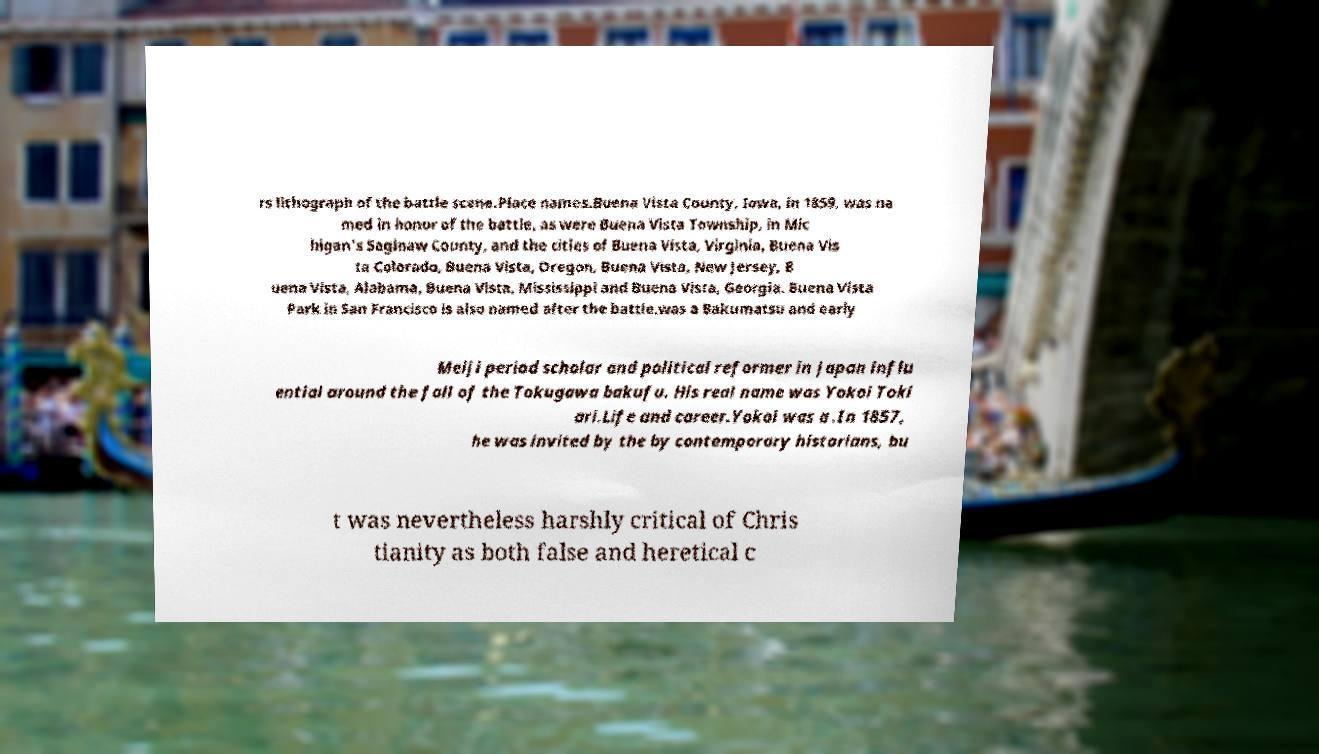For documentation purposes, I need the text within this image transcribed. Could you provide that? rs lithograph of the battle scene.Place names.Buena Vista County, Iowa, in 1859, was na med in honor of the battle, as were Buena Vista Township, in Mic higan's Saginaw County, and the cities of Buena Vista, Virginia, Buena Vis ta Colorado, Buena Vista, Oregon, Buena Vista, New Jersey, B uena Vista, Alabama, Buena Vista, Mississippi and Buena Vista, Georgia. Buena Vista Park in San Francisco is also named after the battle.was a Bakumatsu and early Meiji period scholar and political reformer in Japan influ ential around the fall of the Tokugawa bakufu. His real name was Yokoi Toki ari.Life and career.Yokoi was a .In 1857, he was invited by the by contemporary historians, bu t was nevertheless harshly critical of Chris tianity as both false and heretical c 